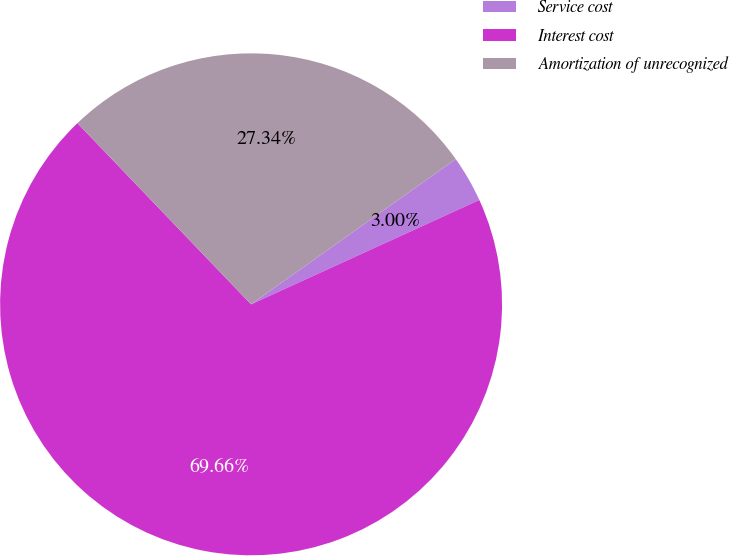Convert chart. <chart><loc_0><loc_0><loc_500><loc_500><pie_chart><fcel>Service cost<fcel>Interest cost<fcel>Amortization of unrecognized<nl><fcel>3.0%<fcel>69.66%<fcel>27.34%<nl></chart> 